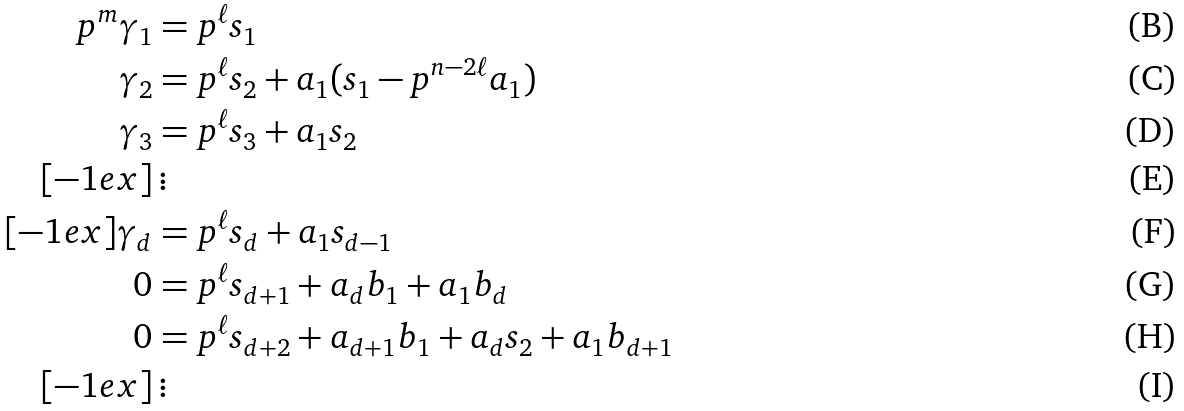<formula> <loc_0><loc_0><loc_500><loc_500>p ^ { m } \gamma _ { 1 } & = p ^ { \ell } s _ { 1 } \\ \gamma _ { 2 } & = p ^ { \ell } s _ { 2 } + a _ { 1 } ( s _ { 1 } - p ^ { n - 2 \ell } a _ { 1 } ) \\ \gamma _ { 3 } & = p ^ { \ell } s _ { 3 } + a _ { 1 } s _ { 2 } \\ [ - 1 e x ] & \, \vdots \\ [ - 1 e x ] \gamma _ { d } & = p ^ { \ell } s _ { d } + a _ { 1 } s _ { d - 1 } \\ 0 & = p ^ { \ell } s _ { d + 1 } + a _ { d } b _ { 1 } + a _ { 1 } b _ { d } \\ 0 & = p ^ { \ell } s _ { d + 2 } + a _ { d + 1 } b _ { 1 } + a _ { d } s _ { 2 } + a _ { 1 } b _ { d + 1 } \\ [ - 1 e x ] & \, \vdots</formula> 